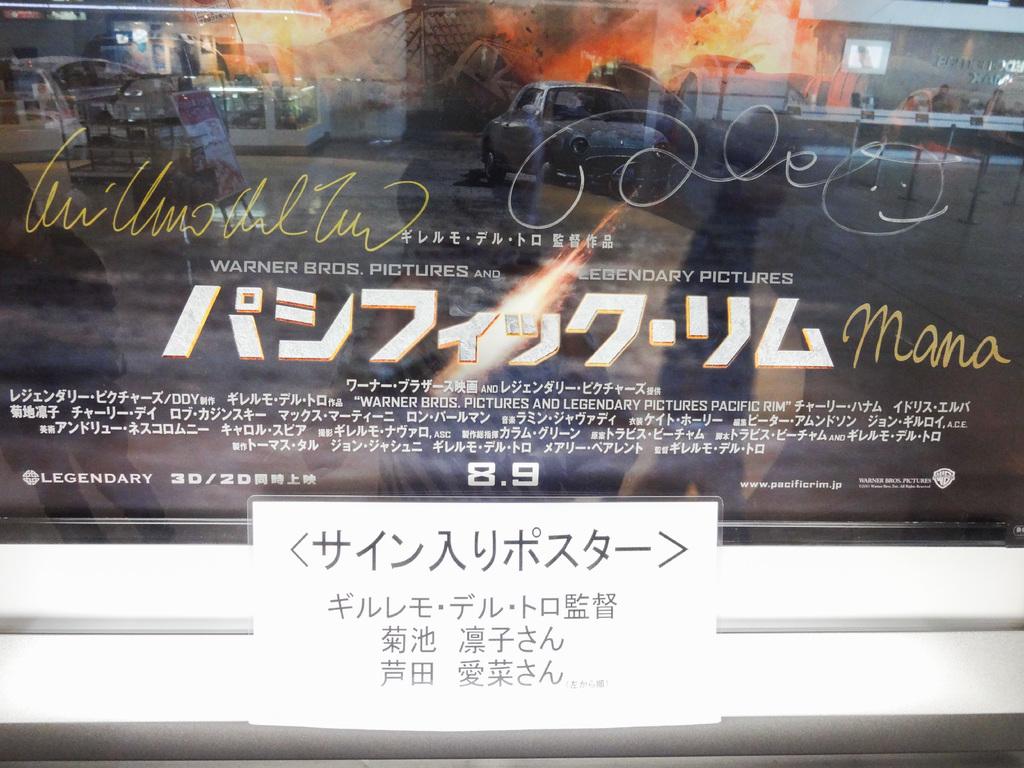What is the text in yellow to the right?
Offer a very short reply. Mana. 